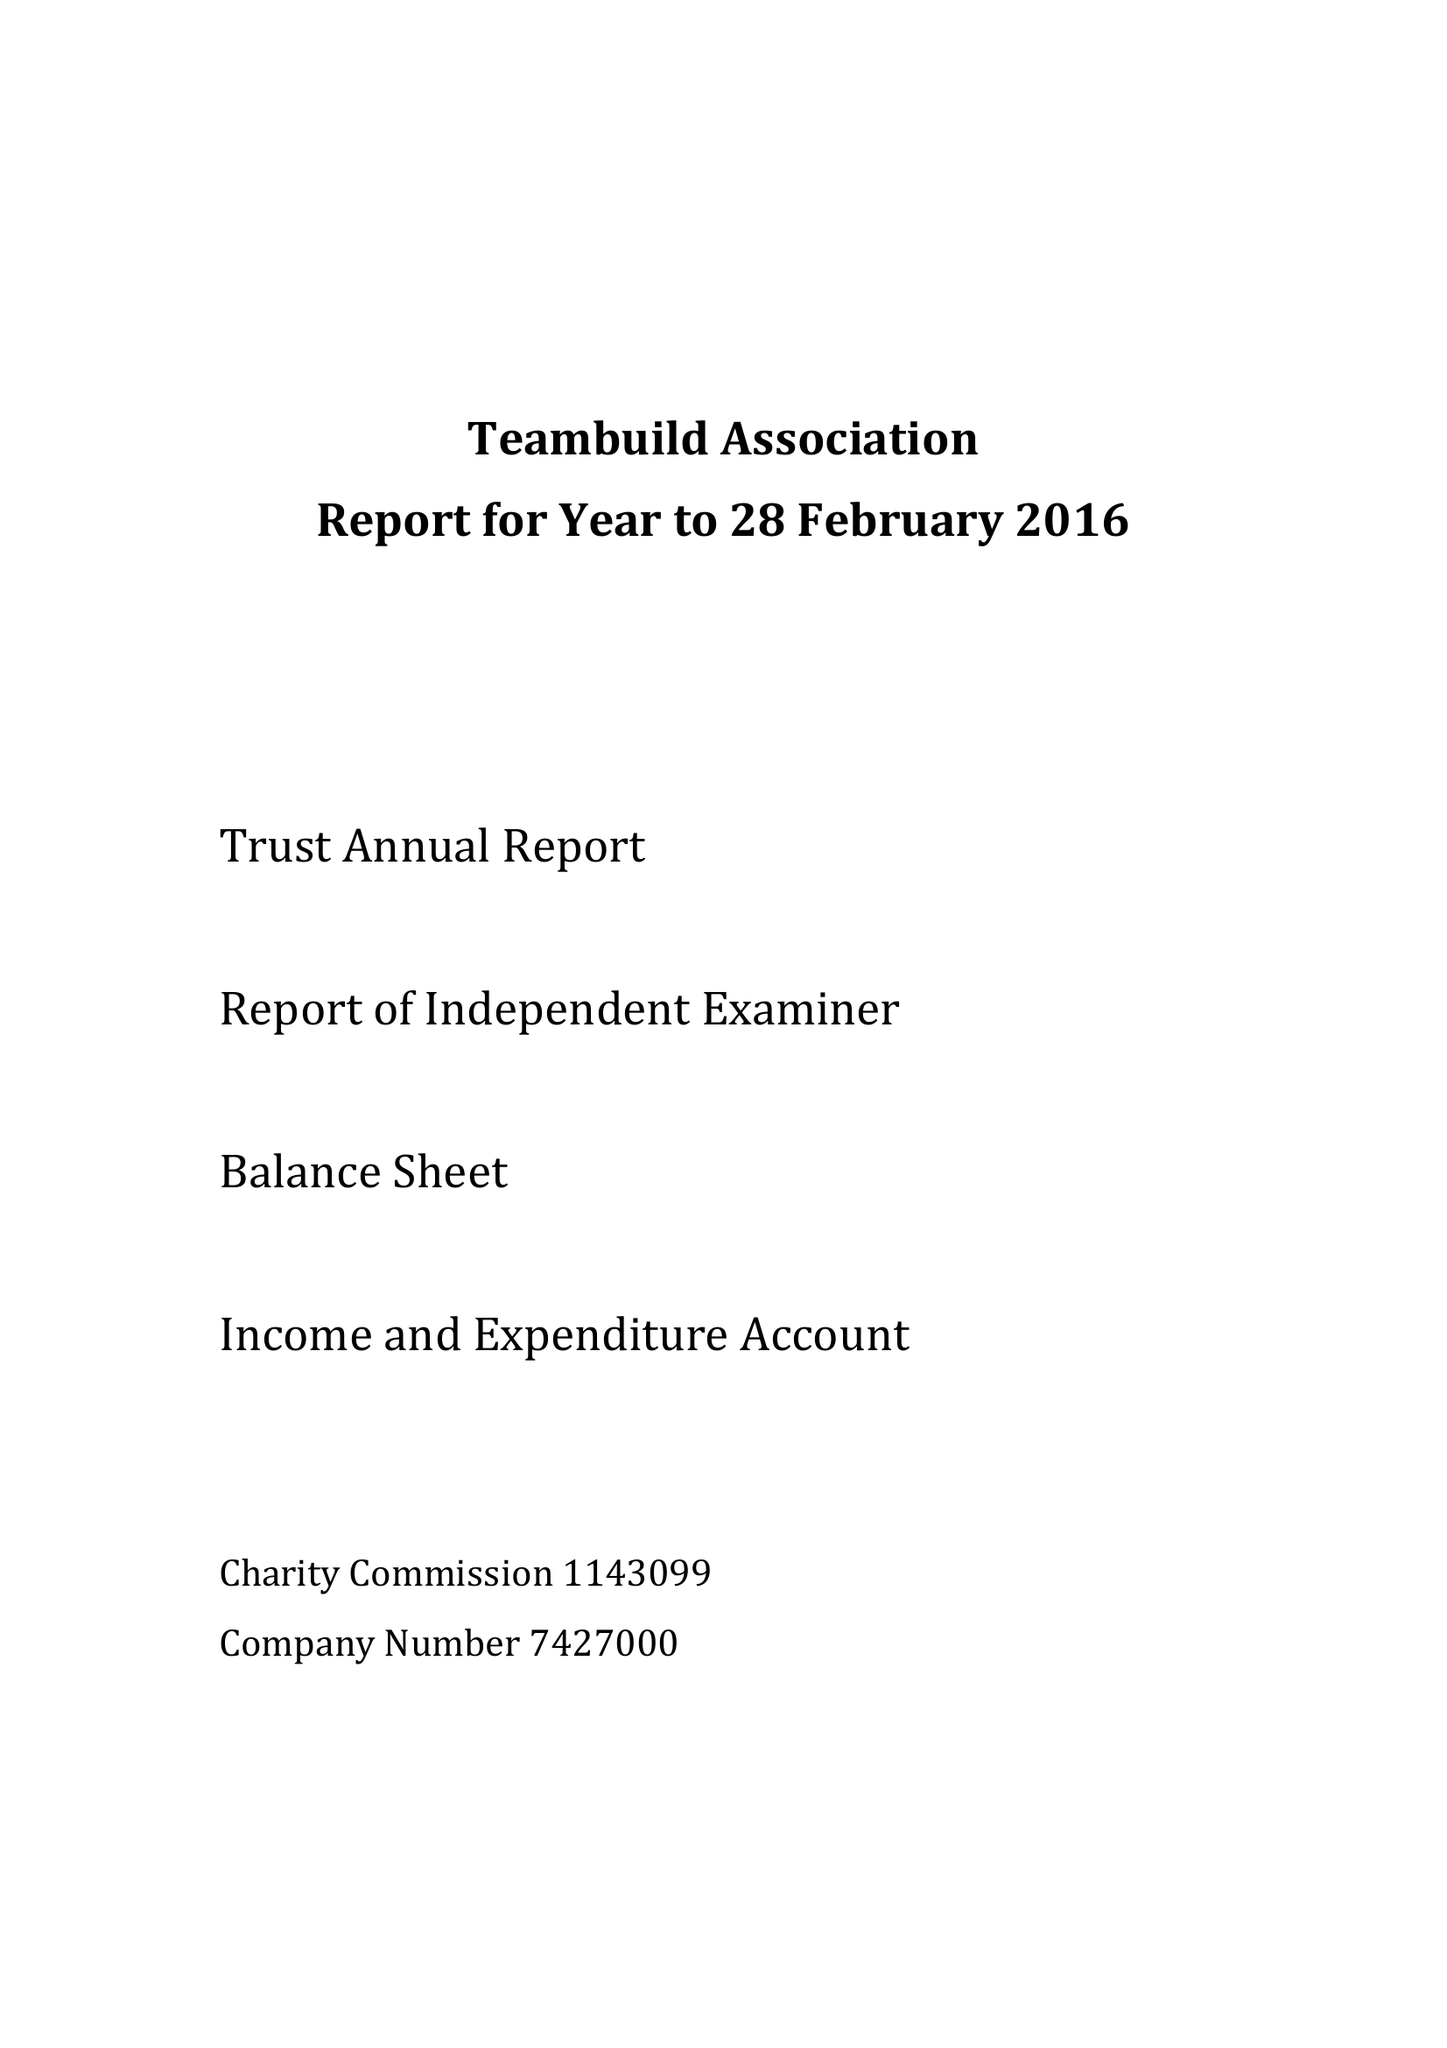What is the value for the income_annually_in_british_pounds?
Answer the question using a single word or phrase. 57856.40 